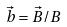Convert formula to latex. <formula><loc_0><loc_0><loc_500><loc_500>\vec { b } = \vec { B } / B</formula> 